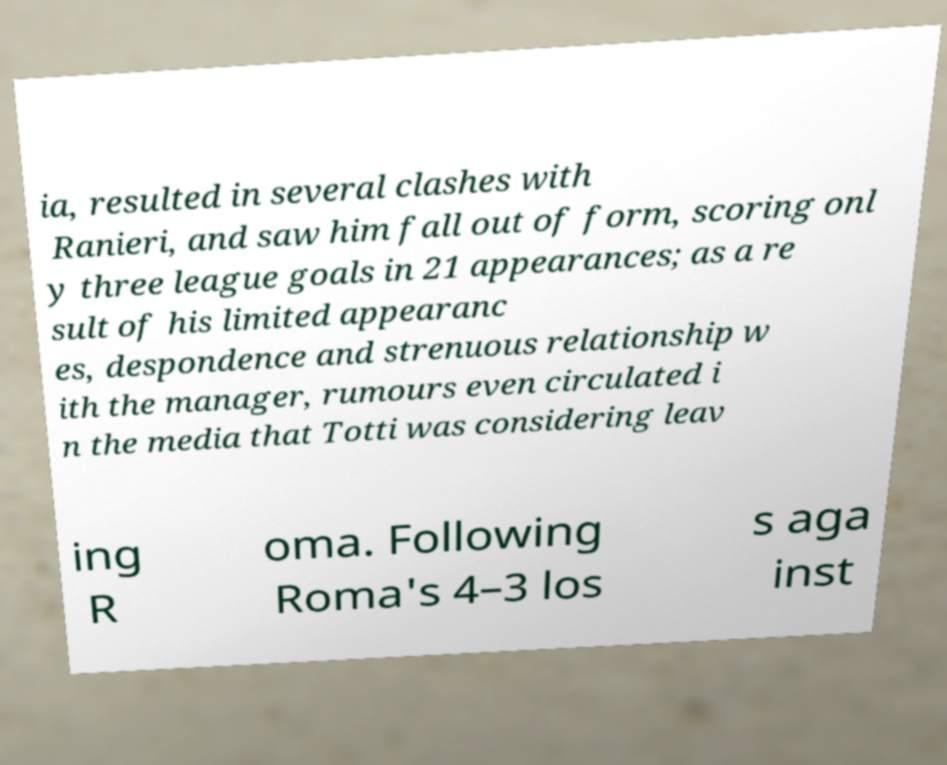Could you extract and type out the text from this image? ia, resulted in several clashes with Ranieri, and saw him fall out of form, scoring onl y three league goals in 21 appearances; as a re sult of his limited appearanc es, despondence and strenuous relationship w ith the manager, rumours even circulated i n the media that Totti was considering leav ing R oma. Following Roma's 4–3 los s aga inst 